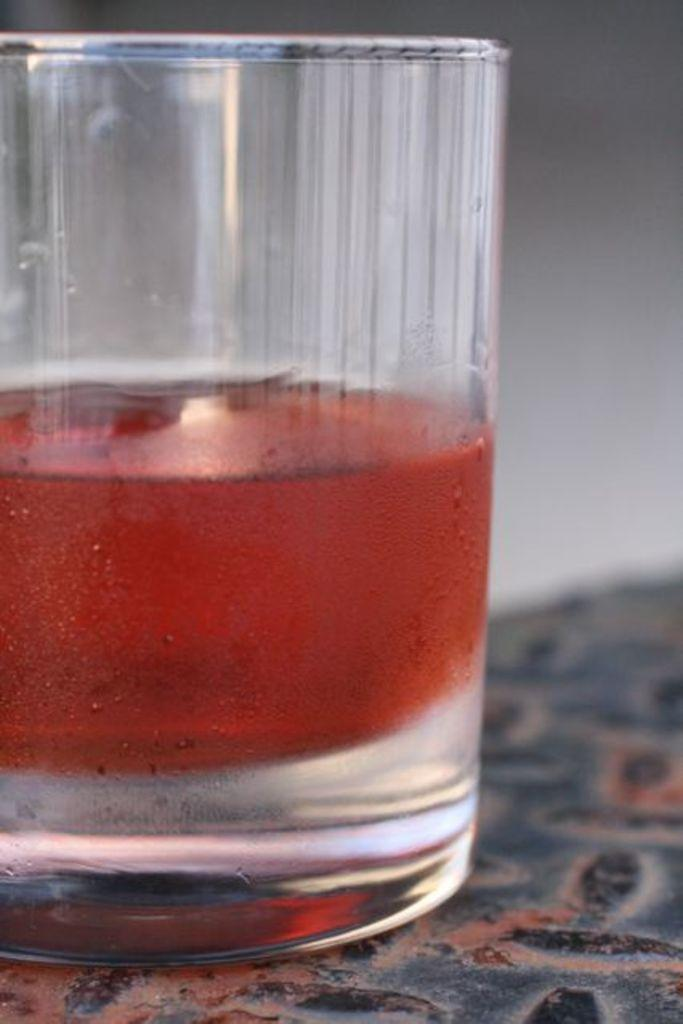What is in the glass that is visible in the image? The glass contains red-colored things. Can you describe the contents of the glass in more detail? Unfortunately, the image is slightly blurry in the background, so it's difficult to determine the exact contents of the glass. How does the drain affect the red-colored things in the glass? There is no drain present in the image, so it cannot affect the red-colored things in the glass. 